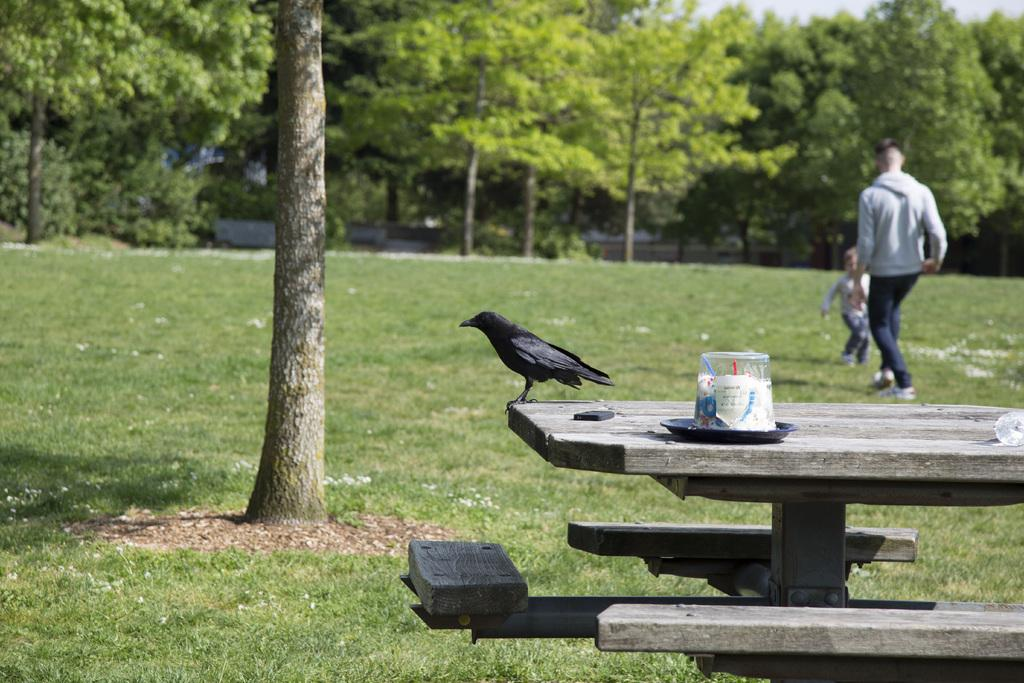What type of setting is depicted in the image? The image is an outdoor scene. What can be seen in the background of the image? There are multiple trees in the distance. What are the people in the image doing? A man and his kids are walking on grass. What furniture is present in the image? There is a table in the image. What is on the table in the image? A bird and a plate are present on the table. Can you describe the detail of the kitty playing with the hen in the image? There is no kitty or hen present in the image. 